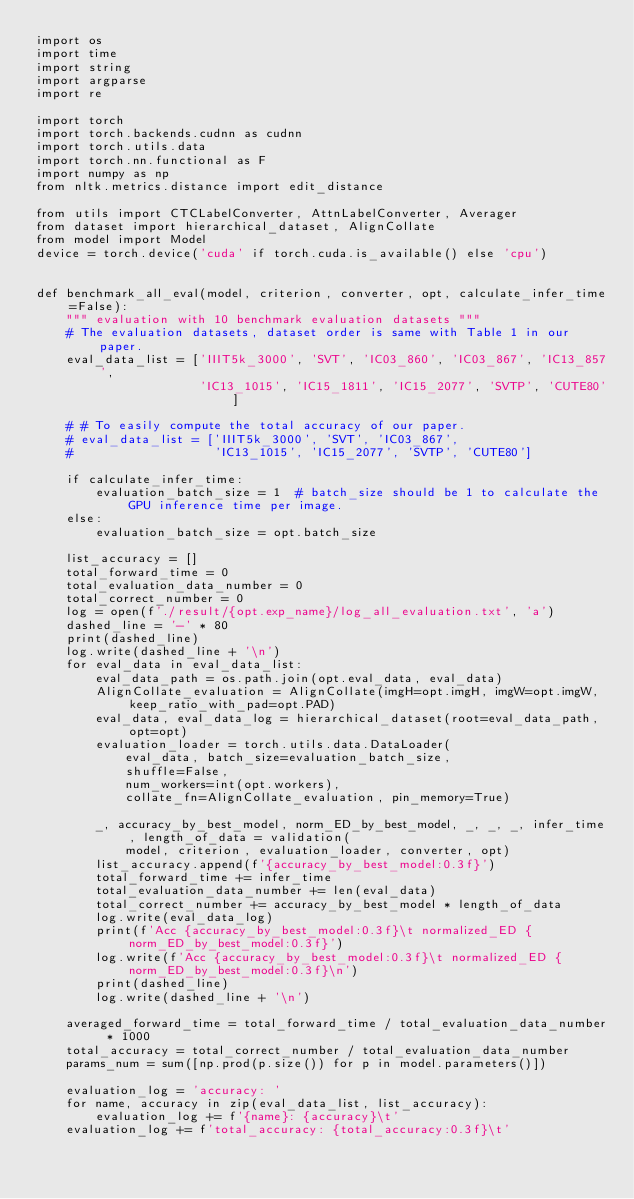Convert code to text. <code><loc_0><loc_0><loc_500><loc_500><_Python_>import os
import time
import string
import argparse
import re

import torch
import torch.backends.cudnn as cudnn
import torch.utils.data
import torch.nn.functional as F
import numpy as np
from nltk.metrics.distance import edit_distance

from utils import CTCLabelConverter, AttnLabelConverter, Averager
from dataset import hierarchical_dataset, AlignCollate
from model import Model
device = torch.device('cuda' if torch.cuda.is_available() else 'cpu')


def benchmark_all_eval(model, criterion, converter, opt, calculate_infer_time=False):
    """ evaluation with 10 benchmark evaluation datasets """
    # The evaluation datasets, dataset order is same with Table 1 in our paper.
    eval_data_list = ['IIIT5k_3000', 'SVT', 'IC03_860', 'IC03_867', 'IC13_857',
                      'IC13_1015', 'IC15_1811', 'IC15_2077', 'SVTP', 'CUTE80']

    # # To easily compute the total accuracy of our paper.
    # eval_data_list = ['IIIT5k_3000', 'SVT', 'IC03_867', 
    #                   'IC13_1015', 'IC15_2077', 'SVTP', 'CUTE80']

    if calculate_infer_time:
        evaluation_batch_size = 1  # batch_size should be 1 to calculate the GPU inference time per image.
    else:
        evaluation_batch_size = opt.batch_size

    list_accuracy = []
    total_forward_time = 0
    total_evaluation_data_number = 0
    total_correct_number = 0
    log = open(f'./result/{opt.exp_name}/log_all_evaluation.txt', 'a')
    dashed_line = '-' * 80
    print(dashed_line)
    log.write(dashed_line + '\n')
    for eval_data in eval_data_list:
        eval_data_path = os.path.join(opt.eval_data, eval_data)
        AlignCollate_evaluation = AlignCollate(imgH=opt.imgH, imgW=opt.imgW, keep_ratio_with_pad=opt.PAD)
        eval_data, eval_data_log = hierarchical_dataset(root=eval_data_path, opt=opt)
        evaluation_loader = torch.utils.data.DataLoader(
            eval_data, batch_size=evaluation_batch_size,
            shuffle=False,
            num_workers=int(opt.workers),
            collate_fn=AlignCollate_evaluation, pin_memory=True)

        _, accuracy_by_best_model, norm_ED_by_best_model, _, _, _, infer_time, length_of_data = validation(
            model, criterion, evaluation_loader, converter, opt)
        list_accuracy.append(f'{accuracy_by_best_model:0.3f}')
        total_forward_time += infer_time
        total_evaluation_data_number += len(eval_data)
        total_correct_number += accuracy_by_best_model * length_of_data
        log.write(eval_data_log)
        print(f'Acc {accuracy_by_best_model:0.3f}\t normalized_ED {norm_ED_by_best_model:0.3f}')
        log.write(f'Acc {accuracy_by_best_model:0.3f}\t normalized_ED {norm_ED_by_best_model:0.3f}\n')
        print(dashed_line)
        log.write(dashed_line + '\n')

    averaged_forward_time = total_forward_time / total_evaluation_data_number * 1000
    total_accuracy = total_correct_number / total_evaluation_data_number
    params_num = sum([np.prod(p.size()) for p in model.parameters()])

    evaluation_log = 'accuracy: '
    for name, accuracy in zip(eval_data_list, list_accuracy):
        evaluation_log += f'{name}: {accuracy}\t'
    evaluation_log += f'total_accuracy: {total_accuracy:0.3f}\t'</code> 